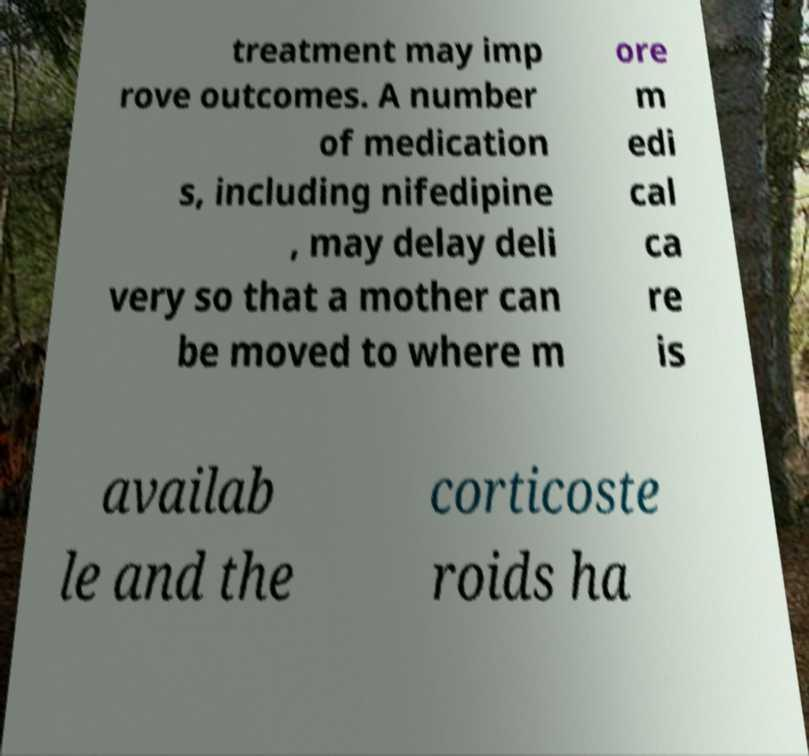Please identify and transcribe the text found in this image. treatment may imp rove outcomes. A number of medication s, including nifedipine , may delay deli very so that a mother can be moved to where m ore m edi cal ca re is availab le and the corticoste roids ha 